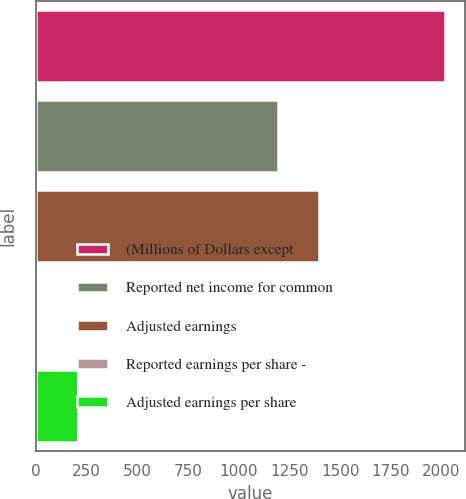Convert chart. <chart><loc_0><loc_0><loc_500><loc_500><bar_chart><fcel>(Millions of Dollars except<fcel>Reported net income for common<fcel>Adjusted earnings<fcel>Reported earnings per share -<fcel>Adjusted earnings per share<nl><fcel>2015<fcel>1193<fcel>1394.09<fcel>4.07<fcel>205.16<nl></chart> 